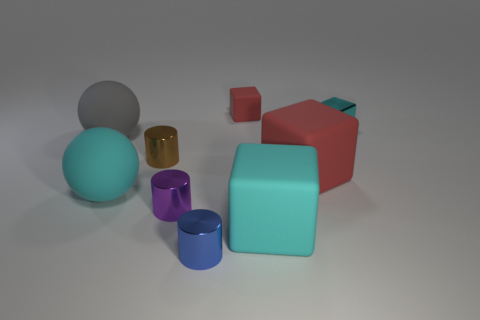Subtract all small purple metallic cylinders. How many cylinders are left? 2 Subtract all red cubes. How many cubes are left? 2 Subtract 2 blocks. How many blocks are left? 2 Subtract all red balls. How many red blocks are left? 2 Add 1 small purple cylinders. How many objects exist? 10 Subtract 0 red spheres. How many objects are left? 9 Subtract all cylinders. How many objects are left? 6 Subtract all red spheres. Subtract all brown cylinders. How many spheres are left? 2 Subtract all red objects. Subtract all small cyan matte blocks. How many objects are left? 7 Add 8 tiny brown metal cylinders. How many tiny brown metal cylinders are left? 9 